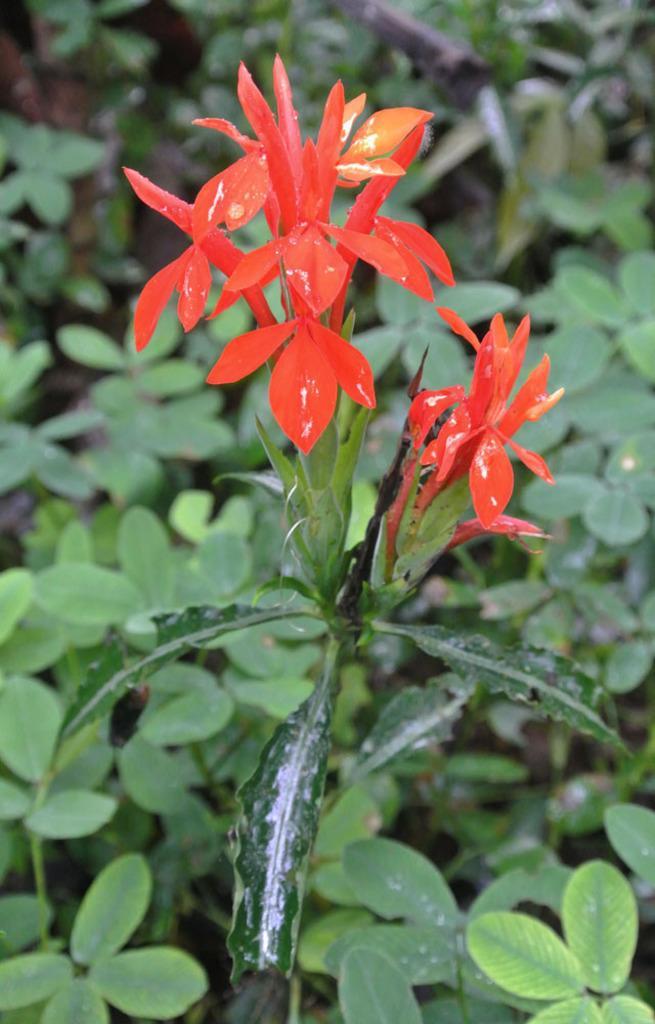Please provide a concise description of this image. In this image, we can see some plant which are green in color and there is a flower on a plant which is reddish orange in color. 